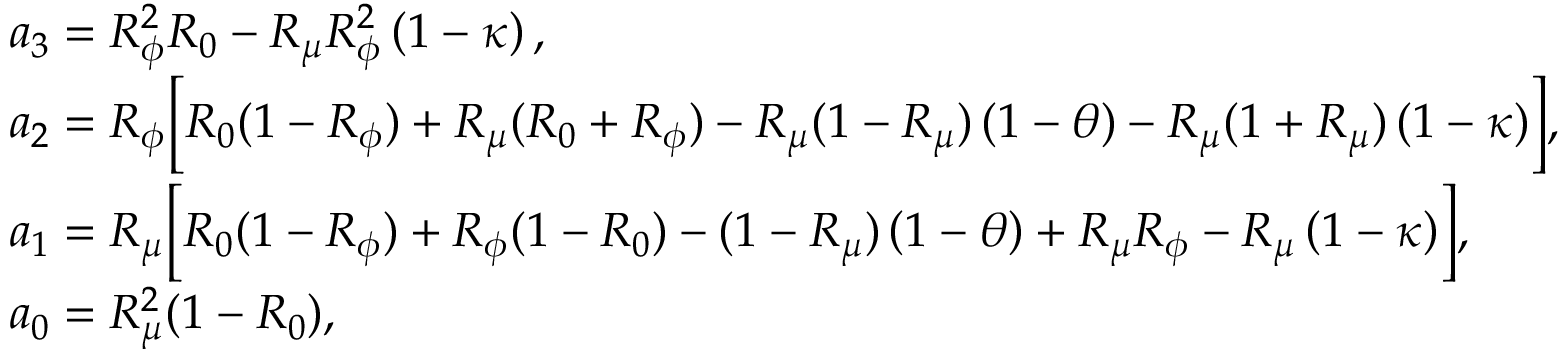<formula> <loc_0><loc_0><loc_500><loc_500>\begin{array} { r l } & { a _ { 3 } = R _ { \phi } ^ { 2 } R _ { 0 } - R _ { \mu } R _ { \phi } ^ { 2 } \left ( 1 - \kappa \right ) , } \\ & { a _ { 2 } = R _ { \phi } \left [ R _ { 0 } ( 1 - R _ { \phi } ) + R _ { \mu } ( R _ { 0 } + R _ { \phi } ) - R _ { \mu } ( 1 - R _ { \mu } ) \left ( 1 - \theta \right ) - R _ { \mu } ( 1 + R _ { \mu } ) \left ( 1 - \kappa \right ) \right ] , } \\ & { a _ { 1 } = R _ { \mu } \left [ R _ { 0 } ( 1 - R _ { \phi } ) + R _ { \phi } ( 1 - R _ { 0 } ) - ( 1 - R _ { \mu } ) \left ( 1 - \theta \right ) + R _ { \mu } R _ { \phi } - R _ { \mu } \left ( 1 - \kappa \right ) \right ] , } \\ & { a _ { 0 } = R _ { \mu } ^ { 2 } ( 1 - R _ { 0 } ) , } \end{array}</formula> 